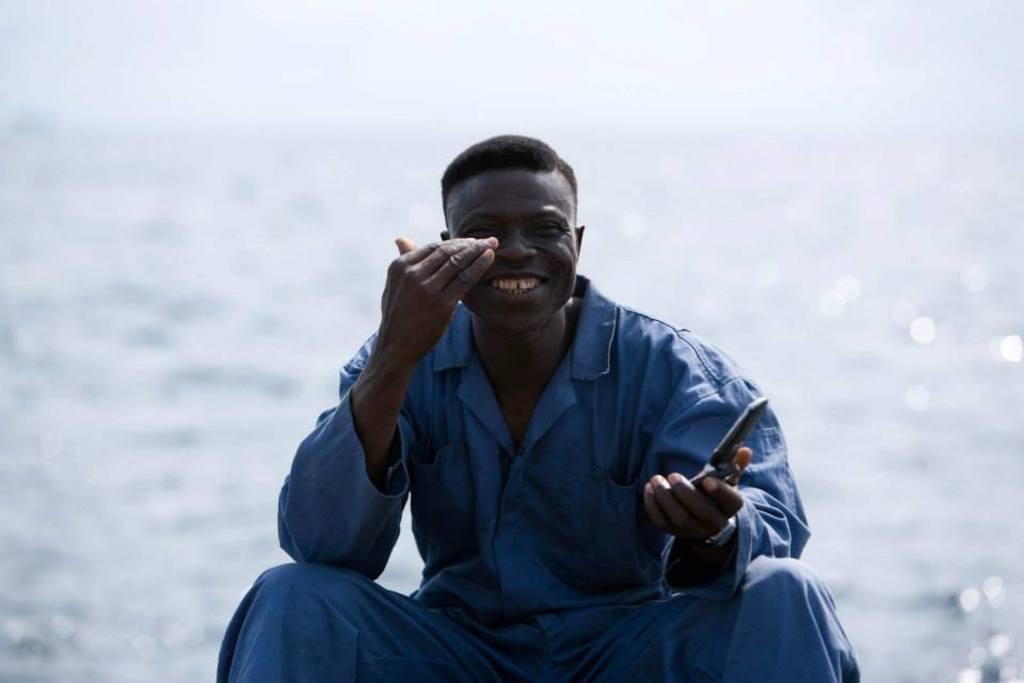How would you summarize this image in a sentence or two? In the center of the picture there is a person in blue dress, holding a knife. In the background there is a water body. 